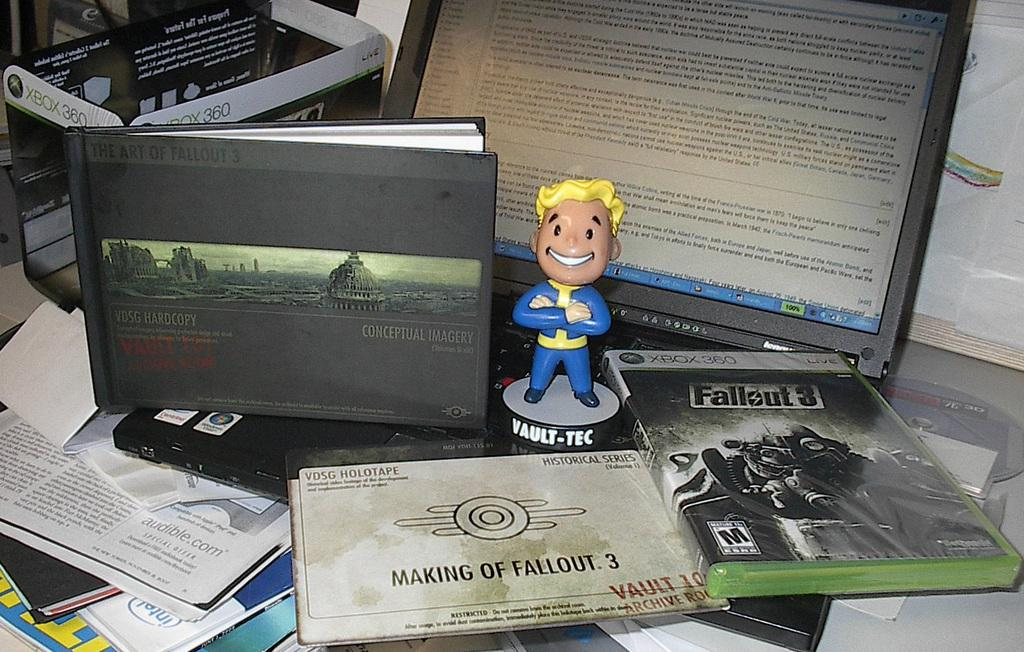<image>
Provide a brief description of the given image. a bobble head and fallout 3 merch is llaying on a desk 